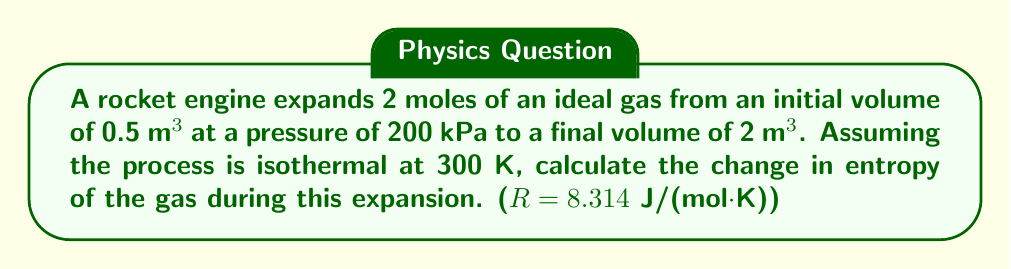Could you help me with this problem? To solve this problem, we'll use the equation for the change in entropy of an ideal gas during an isothermal process:

$$\Delta S = nR \ln\left(\frac{V_f}{V_i}\right)$$

Where:
$\Delta S$ is the change in entropy
$n$ is the number of moles
$R$ is the universal gas constant
$V_f$ is the final volume
$V_i$ is the initial volume

Given:
$n = 2$ moles
$R = 8.314$ J/(mol·K)
$V_i = 0.5$ m³
$V_f = 2$ m³

Step 1: Substitute the values into the equation:

$$\Delta S = 2 \cdot 8.314 \cdot \ln\left(\frac{2}{0.5}\right)$$

Step 2: Simplify the fraction inside the logarithm:

$$\Delta S = 16.628 \cdot \ln(4)$$

Step 3: Calculate the natural logarithm:

$$\Delta S = 16.628 \cdot 1.3863$$

Step 4: Multiply to get the final result:

$$\Delta S = 23.05 \text{ J/K}$$
Answer: $23.05 \text{ J/K}$ 